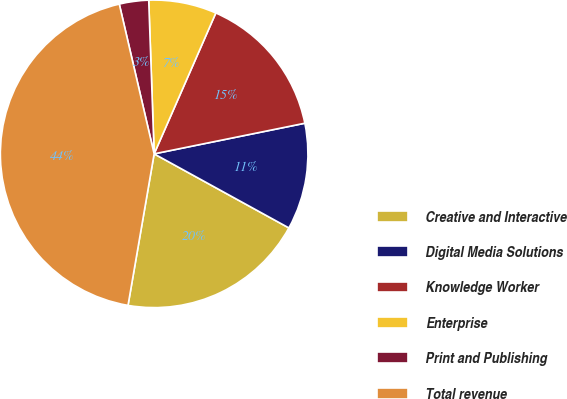Convert chart to OTSL. <chart><loc_0><loc_0><loc_500><loc_500><pie_chart><fcel>Creative and Interactive<fcel>Digital Media Solutions<fcel>Knowledge Worker<fcel>Enterprise<fcel>Print and Publishing<fcel>Total revenue<nl><fcel>19.72%<fcel>11.19%<fcel>15.24%<fcel>7.13%<fcel>3.08%<fcel>43.64%<nl></chart> 